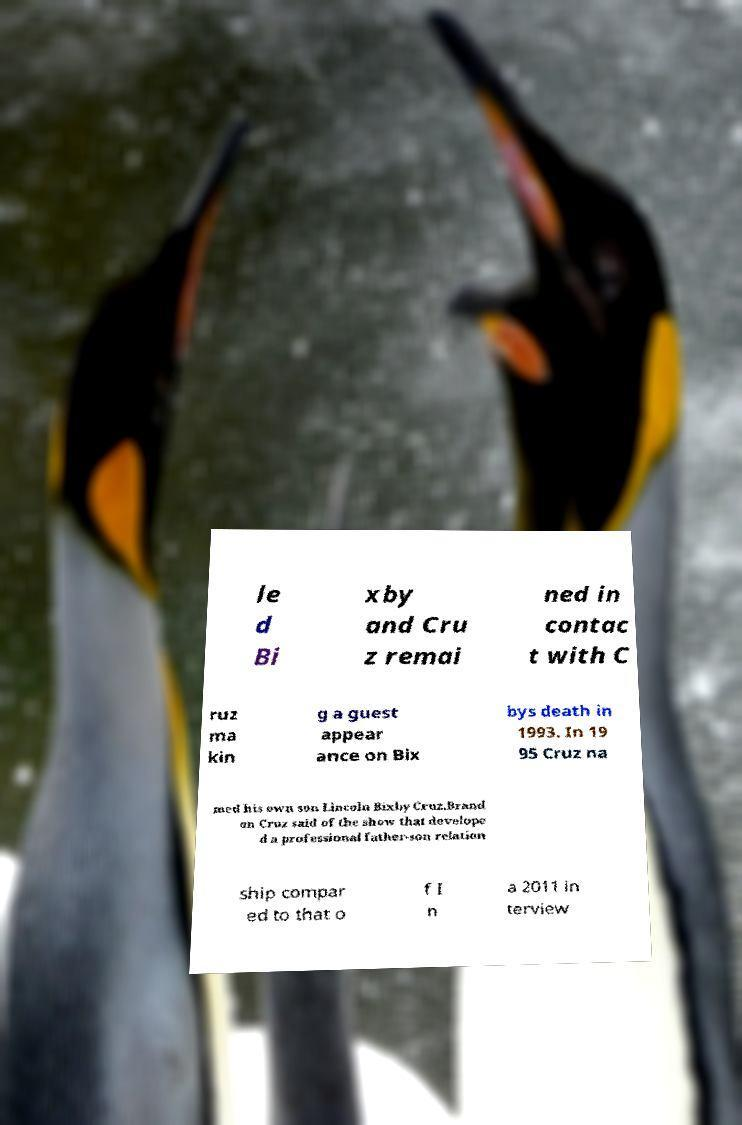Please identify and transcribe the text found in this image. le d Bi xby and Cru z remai ned in contac t with C ruz ma kin g a guest appear ance on Bix bys death in 1993. In 19 95 Cruz na med his own son Lincoln Bixby Cruz.Brand on Cruz said of the show that develope d a professional father-son relation ship compar ed to that o f I n a 2011 in terview 